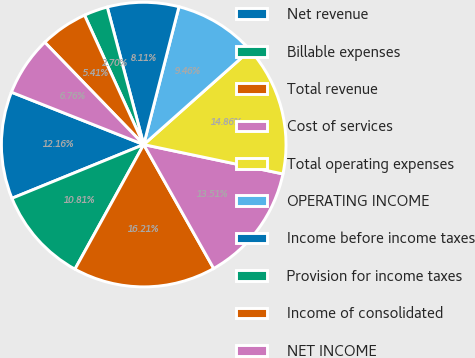<chart> <loc_0><loc_0><loc_500><loc_500><pie_chart><fcel>Net revenue<fcel>Billable expenses<fcel>Total revenue<fcel>Cost of services<fcel>Total operating expenses<fcel>OPERATING INCOME<fcel>Income before income taxes<fcel>Provision for income taxes<fcel>Income of consolidated<fcel>NET INCOME<nl><fcel>12.16%<fcel>10.81%<fcel>16.21%<fcel>13.51%<fcel>14.86%<fcel>9.46%<fcel>8.11%<fcel>2.7%<fcel>5.41%<fcel>6.76%<nl></chart> 